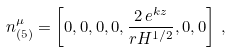<formula> <loc_0><loc_0><loc_500><loc_500>n _ { ( 5 ) } ^ { \mu } = \left [ 0 , 0 , 0 , 0 , \frac { 2 \, e ^ { k z } } { r H ^ { 1 / 2 } } , 0 , 0 \right ] \, ,</formula> 